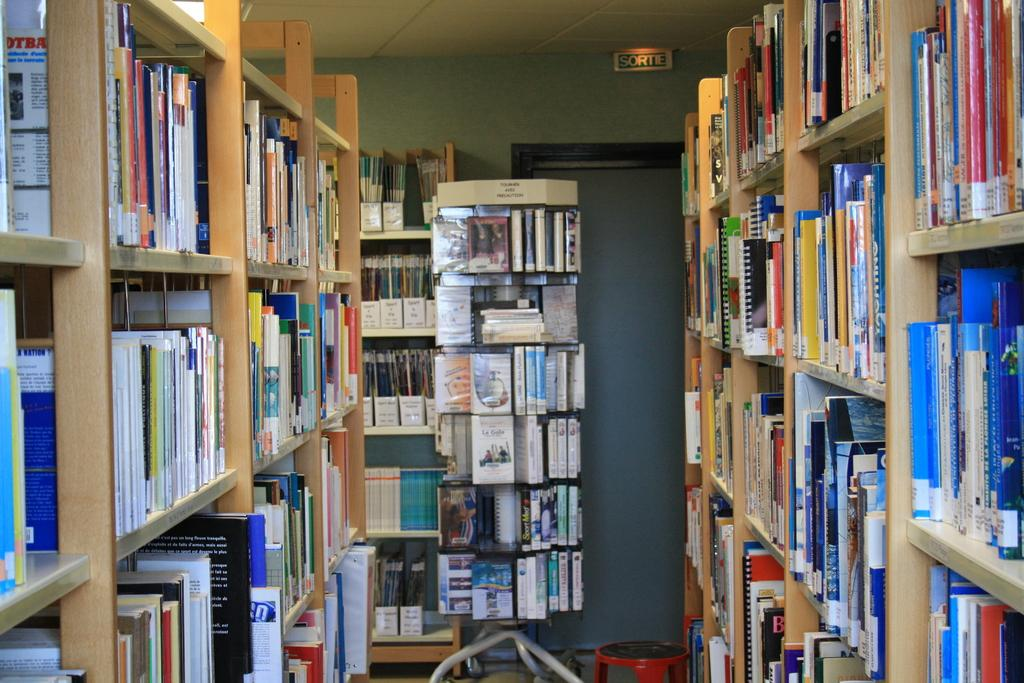What objects are in the image that are used for storing items? There are books in racks in the image. What type of furniture is present in the image? There is a stool in the image. What long, thin objects can be seen in the image? There are rods in the image. What is used for displaying names or labels in the image? There is a name board in the image. What can be seen in the background of the image? There is a wall visible in the background of the image. How many babies are crawling on the stool in the image? There are no babies present in the image; only books, racks, a stool, rods, a name board, and a wall can be seen. 